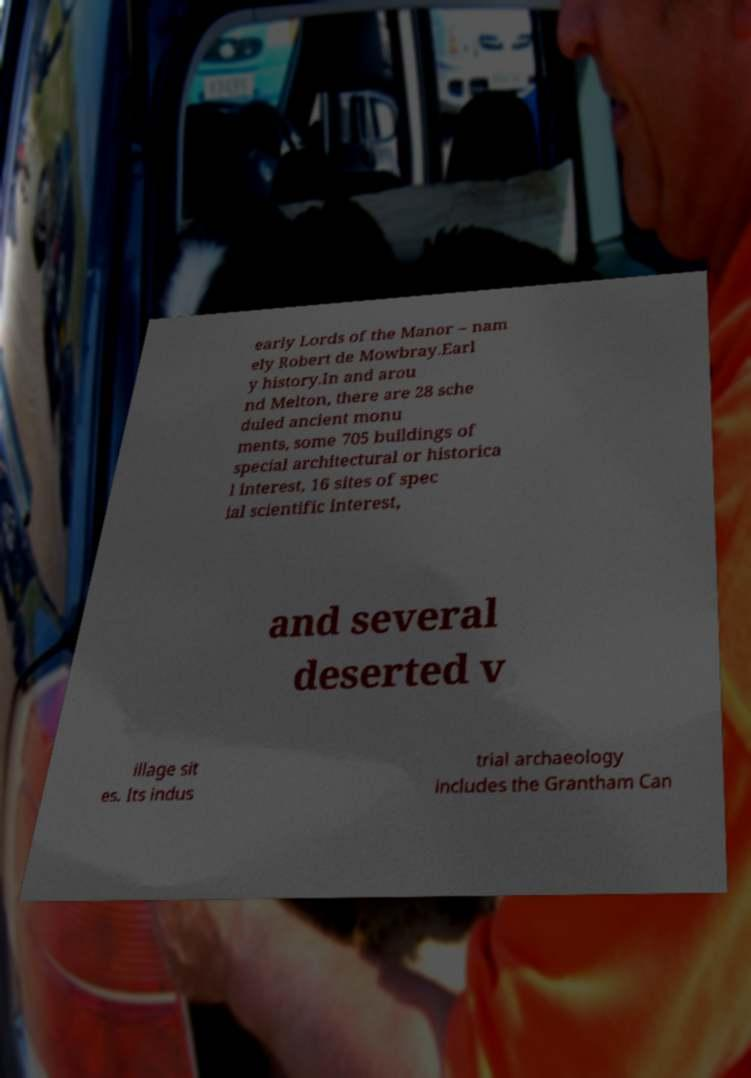Could you extract and type out the text from this image? early Lords of the Manor – nam ely Robert de Mowbray.Earl y history.In and arou nd Melton, there are 28 sche duled ancient monu ments, some 705 buildings of special architectural or historica l interest, 16 sites of spec ial scientific interest, and several deserted v illage sit es. Its indus trial archaeology includes the Grantham Can 